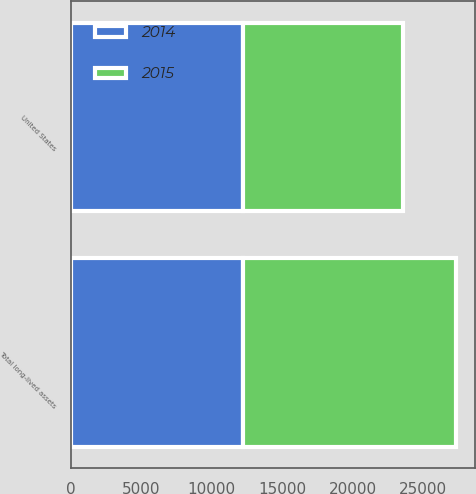Convert chart. <chart><loc_0><loc_0><loc_500><loc_500><stacked_bar_chart><ecel><fcel>United States<fcel>Total long-lived assets<nl><fcel>2015<fcel>11327<fcel>15068<nl><fcel>2014<fcel>12257<fcel>12257<nl></chart> 